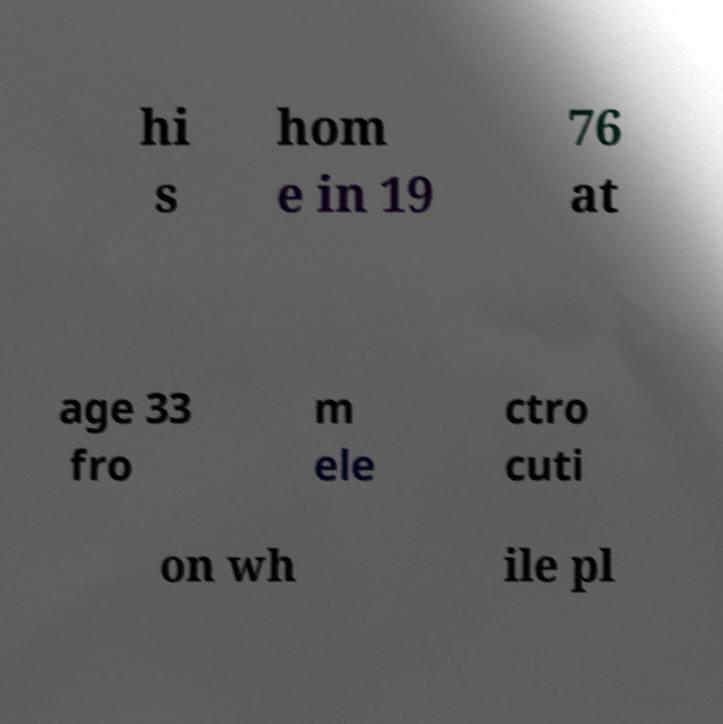Please read and relay the text visible in this image. What does it say? hi s hom e in 19 76 at age 33 fro m ele ctro cuti on wh ile pl 